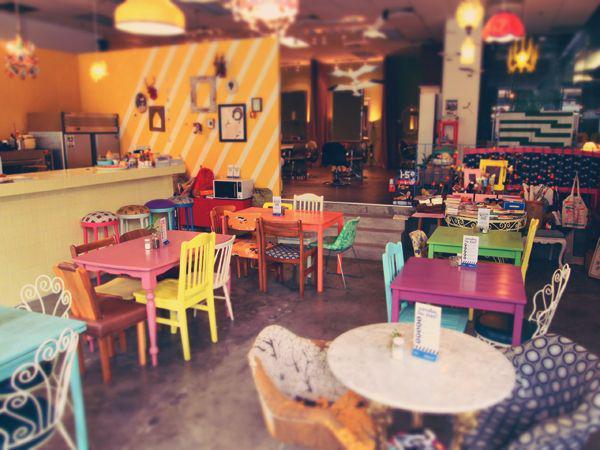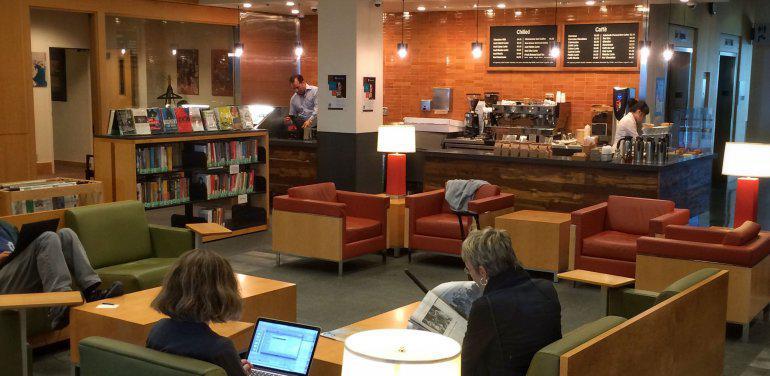The first image is the image on the left, the second image is the image on the right. For the images displayed, is the sentence "In one of the images, the people shop are sitting and reading." factually correct? Answer yes or no. Yes. The first image is the image on the left, the second image is the image on the right. Considering the images on both sides, is "There are at least two people in the bookstore, one adult and one child reading." valid? Answer yes or no. No. 